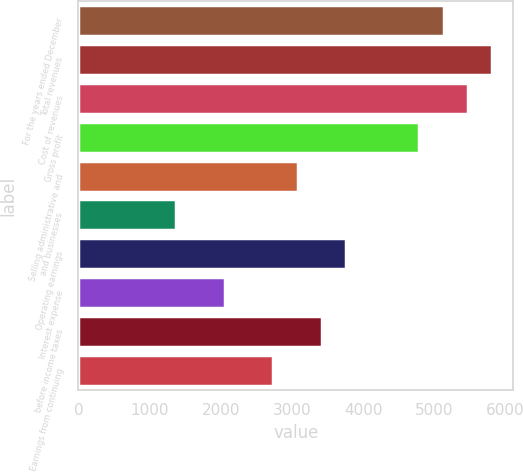Convert chart. <chart><loc_0><loc_0><loc_500><loc_500><bar_chart><fcel>For the years ended December<fcel>Total revenues<fcel>Cost of revenues<fcel>Gross profit<fcel>Selling administrative and<fcel>and businesses<fcel>Operating earnings<fcel>Interest expense<fcel>before income taxes<fcel>Earnings from continuing<nl><fcel>5133.24<fcel>5817.66<fcel>5475.45<fcel>4791.03<fcel>3079.98<fcel>1368.93<fcel>3764.4<fcel>2053.35<fcel>3422.19<fcel>2737.77<nl></chart> 